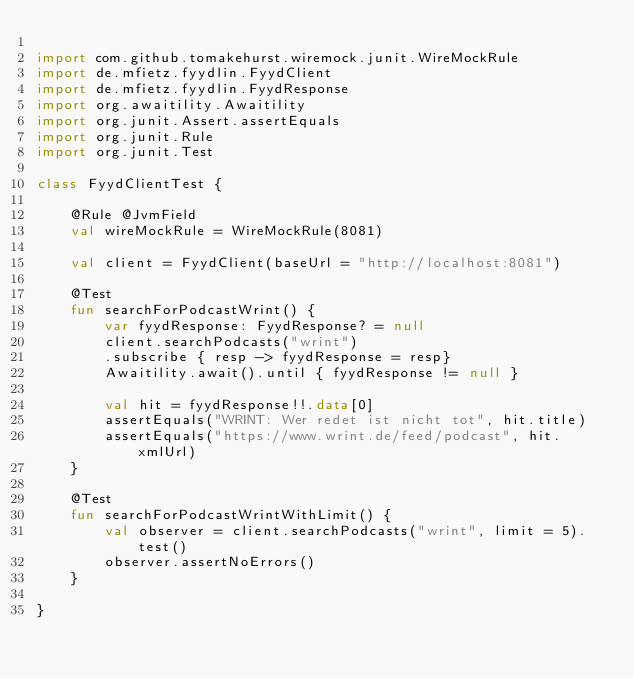Convert code to text. <code><loc_0><loc_0><loc_500><loc_500><_Kotlin_>
import com.github.tomakehurst.wiremock.junit.WireMockRule
import de.mfietz.fyydlin.FyydClient
import de.mfietz.fyydlin.FyydResponse
import org.awaitility.Awaitility
import org.junit.Assert.assertEquals
import org.junit.Rule
import org.junit.Test

class FyydClientTest {

    @Rule @JvmField
    val wireMockRule = WireMockRule(8081)

    val client = FyydClient(baseUrl = "http://localhost:8081")

    @Test
    fun searchForPodcastWrint() {
        var fyydResponse: FyydResponse? = null
        client.searchPodcasts("wrint")
        .subscribe { resp -> fyydResponse = resp}
        Awaitility.await().until { fyydResponse != null }

        val hit = fyydResponse!!.data[0]
        assertEquals("WRINT: Wer redet ist nicht tot", hit.title)
        assertEquals("https://www.wrint.de/feed/podcast", hit.xmlUrl)
    }

    @Test
    fun searchForPodcastWrintWithLimit() {
        val observer = client.searchPodcasts("wrint", limit = 5).test()
        observer.assertNoErrors()
    }

}</code> 